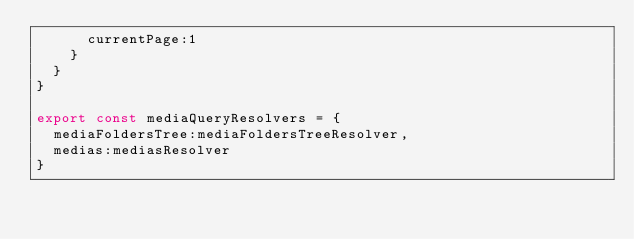Convert code to text. <code><loc_0><loc_0><loc_500><loc_500><_TypeScript_>      currentPage:1
    }
  }
}

export const mediaQueryResolvers = {
  mediaFoldersTree:mediaFoldersTreeResolver,
  medias:mediasResolver
}
</code> 